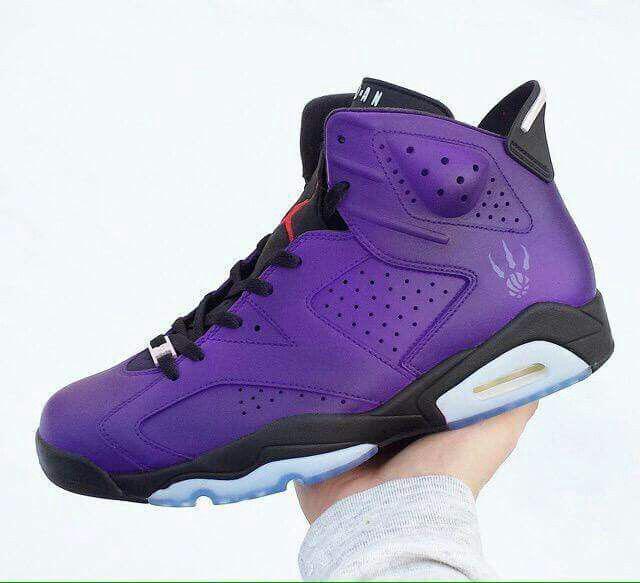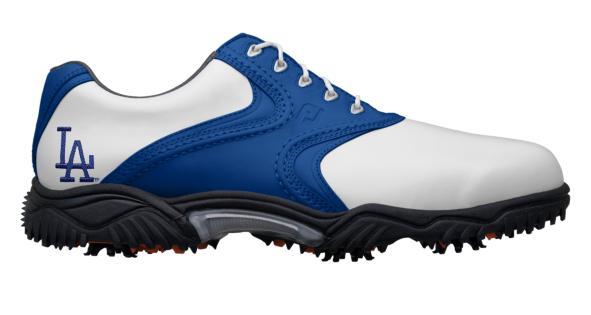The first image is the image on the left, the second image is the image on the right. Examine the images to the left and right. Is the description "In one image, at least one shoe is being worn by a human." accurate? Answer yes or no. No. 